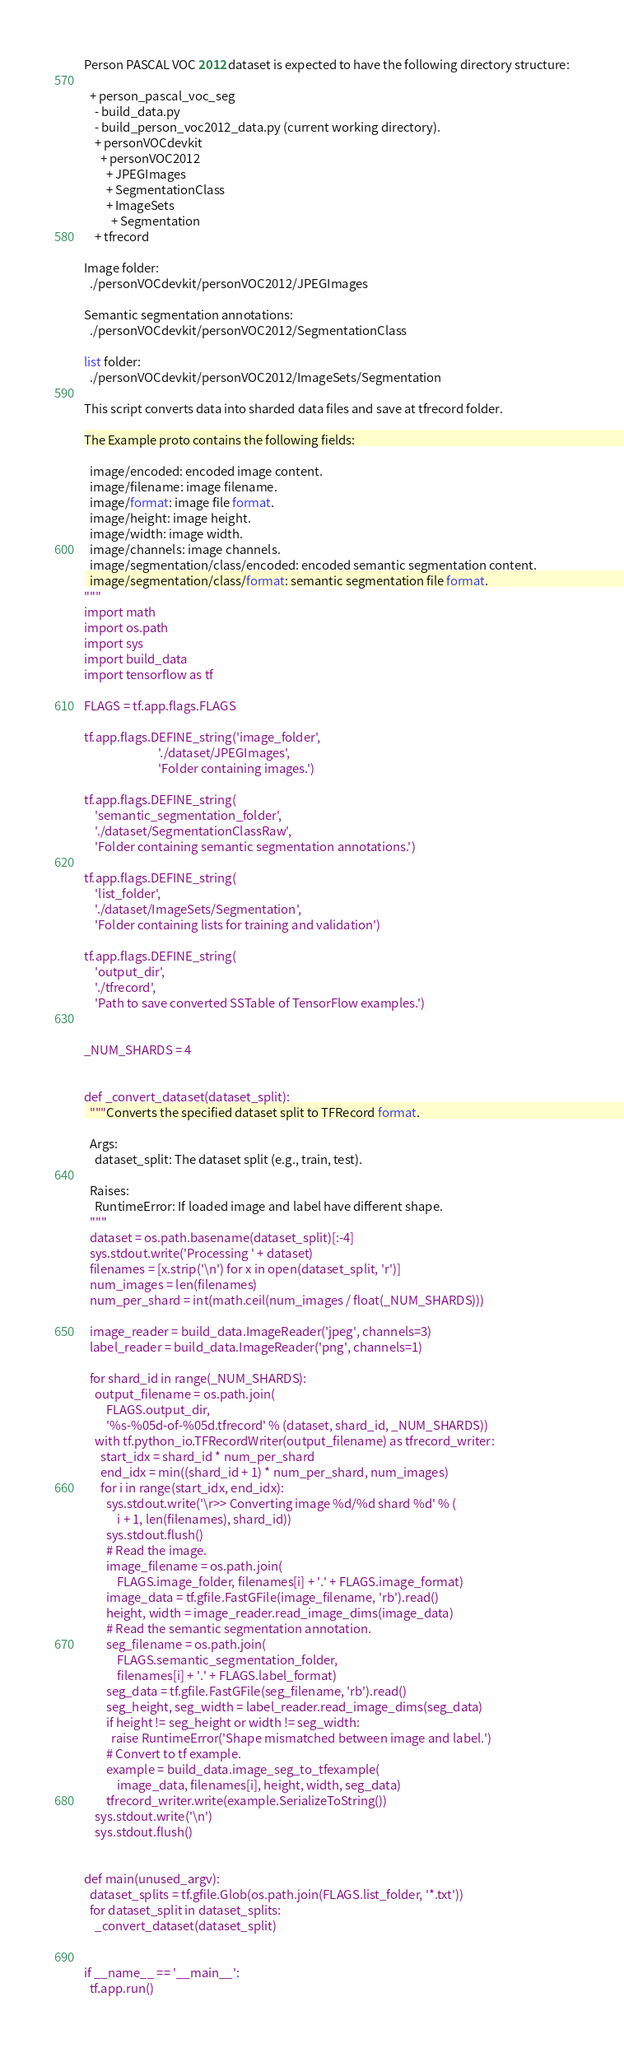Convert code to text. <code><loc_0><loc_0><loc_500><loc_500><_Python_>
Person PASCAL VOC 2012 dataset is expected to have the following directory structure:

  + person_pascal_voc_seg
    - build_data.py
    - build_person_voc2012_data.py (current working directory).
    + personVOCdevkit
      + personVOC2012
        + JPEGImages
        + SegmentationClass
        + ImageSets
          + Segmentation
    + tfrecord

Image folder:
  ./personVOCdevkit/personVOC2012/JPEGImages

Semantic segmentation annotations:
  ./personVOCdevkit/personVOC2012/SegmentationClass

list folder:
  ./personVOCdevkit/personVOC2012/ImageSets/Segmentation

This script converts data into sharded data files and save at tfrecord folder.

The Example proto contains the following fields:

  image/encoded: encoded image content.
  image/filename: image filename.
  image/format: image file format.
  image/height: image height.
  image/width: image width.
  image/channels: image channels.
  image/segmentation/class/encoded: encoded semantic segmentation content.
  image/segmentation/class/format: semantic segmentation file format.
"""
import math
import os.path
import sys
import build_data
import tensorflow as tf

FLAGS = tf.app.flags.FLAGS

tf.app.flags.DEFINE_string('image_folder',
                           './dataset/JPEGImages',
                           'Folder containing images.')

tf.app.flags.DEFINE_string(
    'semantic_segmentation_folder',
    './dataset/SegmentationClassRaw',
    'Folder containing semantic segmentation annotations.')

tf.app.flags.DEFINE_string(
    'list_folder',
    './dataset/ImageSets/Segmentation',
    'Folder containing lists for training and validation')

tf.app.flags.DEFINE_string(
    'output_dir',
    './tfrecord',
    'Path to save converted SSTable of TensorFlow examples.')


_NUM_SHARDS = 4


def _convert_dataset(dataset_split):
  """Converts the specified dataset split to TFRecord format.

  Args:
    dataset_split: The dataset split (e.g., train, test).

  Raises:
    RuntimeError: If loaded image and label have different shape.
  """
  dataset = os.path.basename(dataset_split)[:-4]
  sys.stdout.write('Processing ' + dataset)
  filenames = [x.strip('\n') for x in open(dataset_split, 'r')]
  num_images = len(filenames)
  num_per_shard = int(math.ceil(num_images / float(_NUM_SHARDS)))

  image_reader = build_data.ImageReader('jpeg', channels=3)
  label_reader = build_data.ImageReader('png', channels=1)

  for shard_id in range(_NUM_SHARDS):
    output_filename = os.path.join(
        FLAGS.output_dir,
        '%s-%05d-of-%05d.tfrecord' % (dataset, shard_id, _NUM_SHARDS))
    with tf.python_io.TFRecordWriter(output_filename) as tfrecord_writer:
      start_idx = shard_id * num_per_shard
      end_idx = min((shard_id + 1) * num_per_shard, num_images)
      for i in range(start_idx, end_idx):
        sys.stdout.write('\r>> Converting image %d/%d shard %d' % (
            i + 1, len(filenames), shard_id))
        sys.stdout.flush()
        # Read the image.
        image_filename = os.path.join(
            FLAGS.image_folder, filenames[i] + '.' + FLAGS.image_format)
        image_data = tf.gfile.FastGFile(image_filename, 'rb').read()
        height, width = image_reader.read_image_dims(image_data)
        # Read the semantic segmentation annotation.
        seg_filename = os.path.join(
            FLAGS.semantic_segmentation_folder,
            filenames[i] + '.' + FLAGS.label_format)
        seg_data = tf.gfile.FastGFile(seg_filename, 'rb').read()
        seg_height, seg_width = label_reader.read_image_dims(seg_data)
        if height != seg_height or width != seg_width:
          raise RuntimeError('Shape mismatched between image and label.')
        # Convert to tf example.
        example = build_data.image_seg_to_tfexample(
            image_data, filenames[i], height, width, seg_data)
        tfrecord_writer.write(example.SerializeToString())
    sys.stdout.write('\n')
    sys.stdout.flush()


def main(unused_argv):
  dataset_splits = tf.gfile.Glob(os.path.join(FLAGS.list_folder, '*.txt'))
  for dataset_split in dataset_splits:
    _convert_dataset(dataset_split)


if __name__ == '__main__':
  tf.app.run()
</code> 